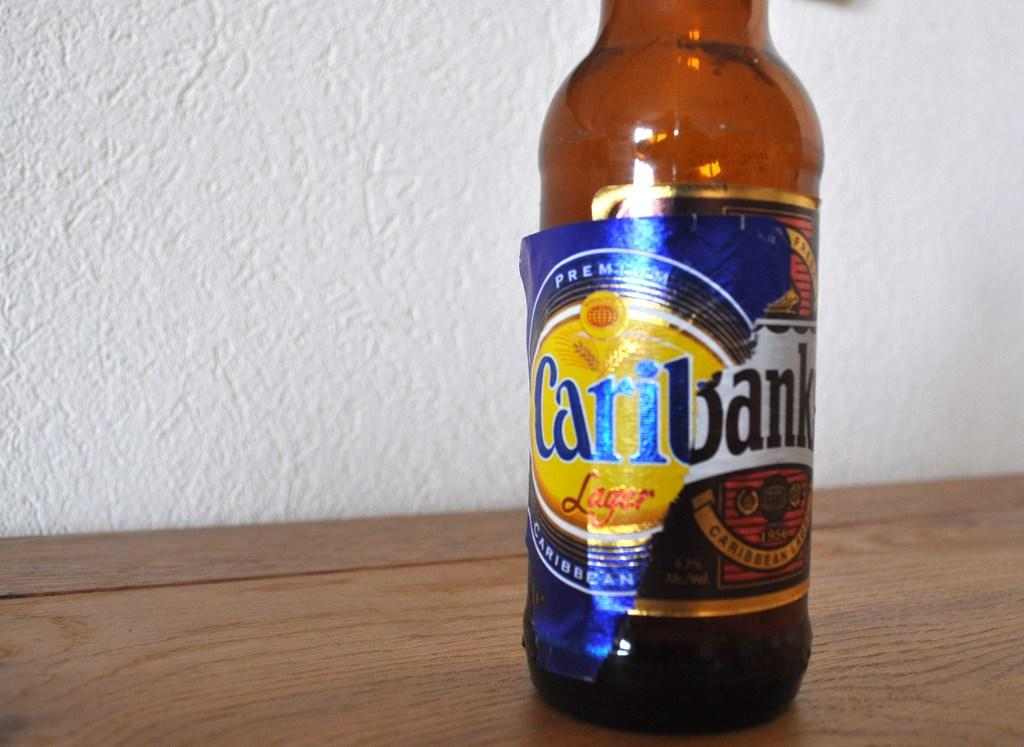Provide a one-sentence caption for the provided image. Bottle of Caribank sits on a wooden table. 